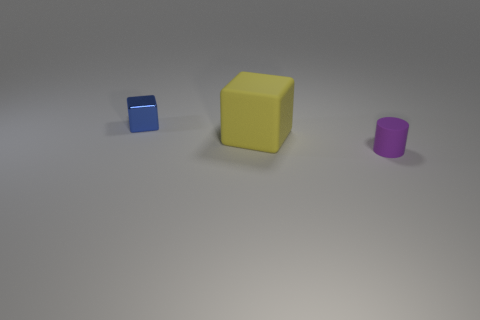Add 1 big rubber things. How many objects exist? 4 Subtract all blocks. How many objects are left? 1 Subtract 0 red blocks. How many objects are left? 3 Subtract all big cubes. Subtract all cubes. How many objects are left? 0 Add 2 purple cylinders. How many purple cylinders are left? 3 Add 2 big purple rubber cylinders. How many big purple rubber cylinders exist? 2 